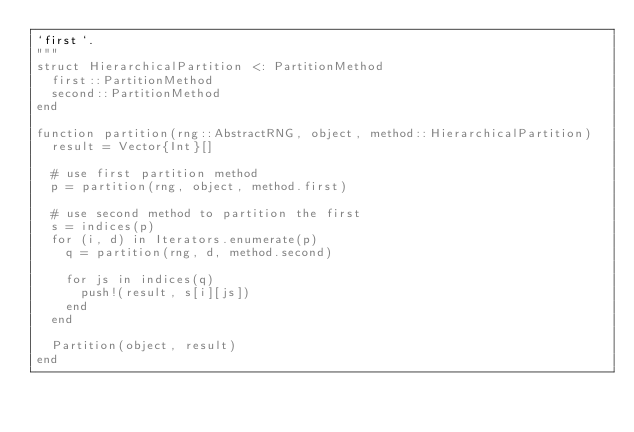<code> <loc_0><loc_0><loc_500><loc_500><_Julia_>`first`.
"""
struct HierarchicalPartition <: PartitionMethod
  first::PartitionMethod
  second::PartitionMethod
end

function partition(rng::AbstractRNG, object, method::HierarchicalPartition)
  result = Vector{Int}[]

  # use first partition method
  p = partition(rng, object, method.first)

  # use second method to partition the first
  s = indices(p)
  for (i, d) in Iterators.enumerate(p)
    q = partition(rng, d, method.second)

    for js in indices(q)
      push!(result, s[i][js])
    end
  end

  Partition(object, result)
end</code> 